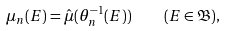Convert formula to latex. <formula><loc_0><loc_0><loc_500><loc_500>\mu _ { n } ( E ) = \hat { \mu } ( \theta _ { n } ^ { - 1 } ( E ) ) \quad ( E \in \mathfrak { B } ) ,</formula> 